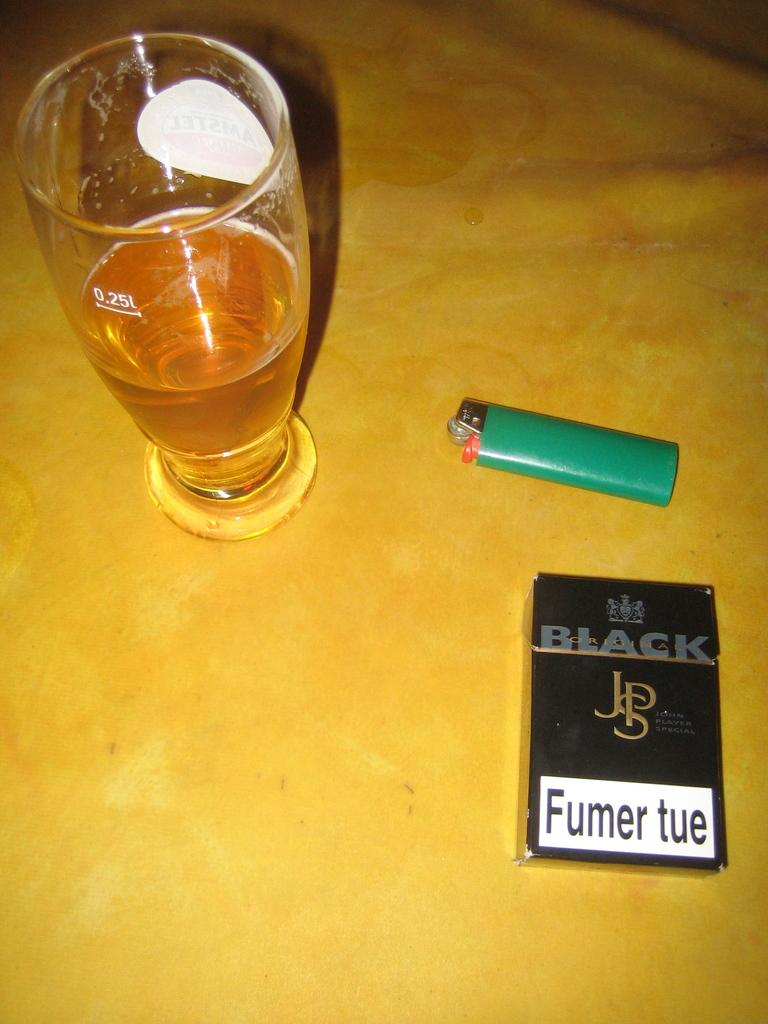<image>
Offer a succinct explanation of the picture presented. a yellow table with a green lighter a glass of beer and a box of cigarrettes that says Fumer tue 